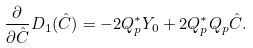<formula> <loc_0><loc_0><loc_500><loc_500>\frac { \partial } { \partial \hat { C } } D _ { 1 } ( \hat { C } ) = - 2 Q _ { p } ^ { * } Y _ { 0 } + 2 Q _ { p } ^ { * } Q _ { p } \hat { C } .</formula> 